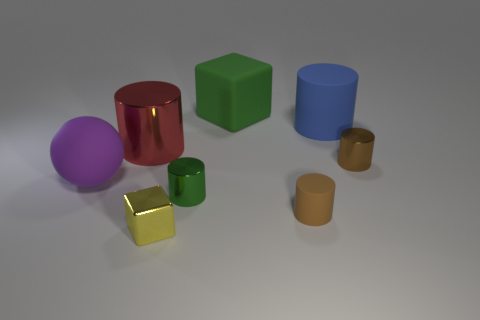Subtract all brown rubber cylinders. How many cylinders are left? 4 Add 2 yellow matte spheres. How many objects exist? 10 Subtract all blue cylinders. How many cylinders are left? 4 Subtract all yellow spheres. How many green cylinders are left? 1 Subtract all gray cylinders. Subtract all yellow spheres. How many cylinders are left? 5 Subtract all blue blocks. Subtract all big green rubber blocks. How many objects are left? 7 Add 6 big green cubes. How many big green cubes are left? 7 Add 4 big blue matte cylinders. How many big blue matte cylinders exist? 5 Subtract 0 gray cylinders. How many objects are left? 8 Subtract all cylinders. How many objects are left? 3 